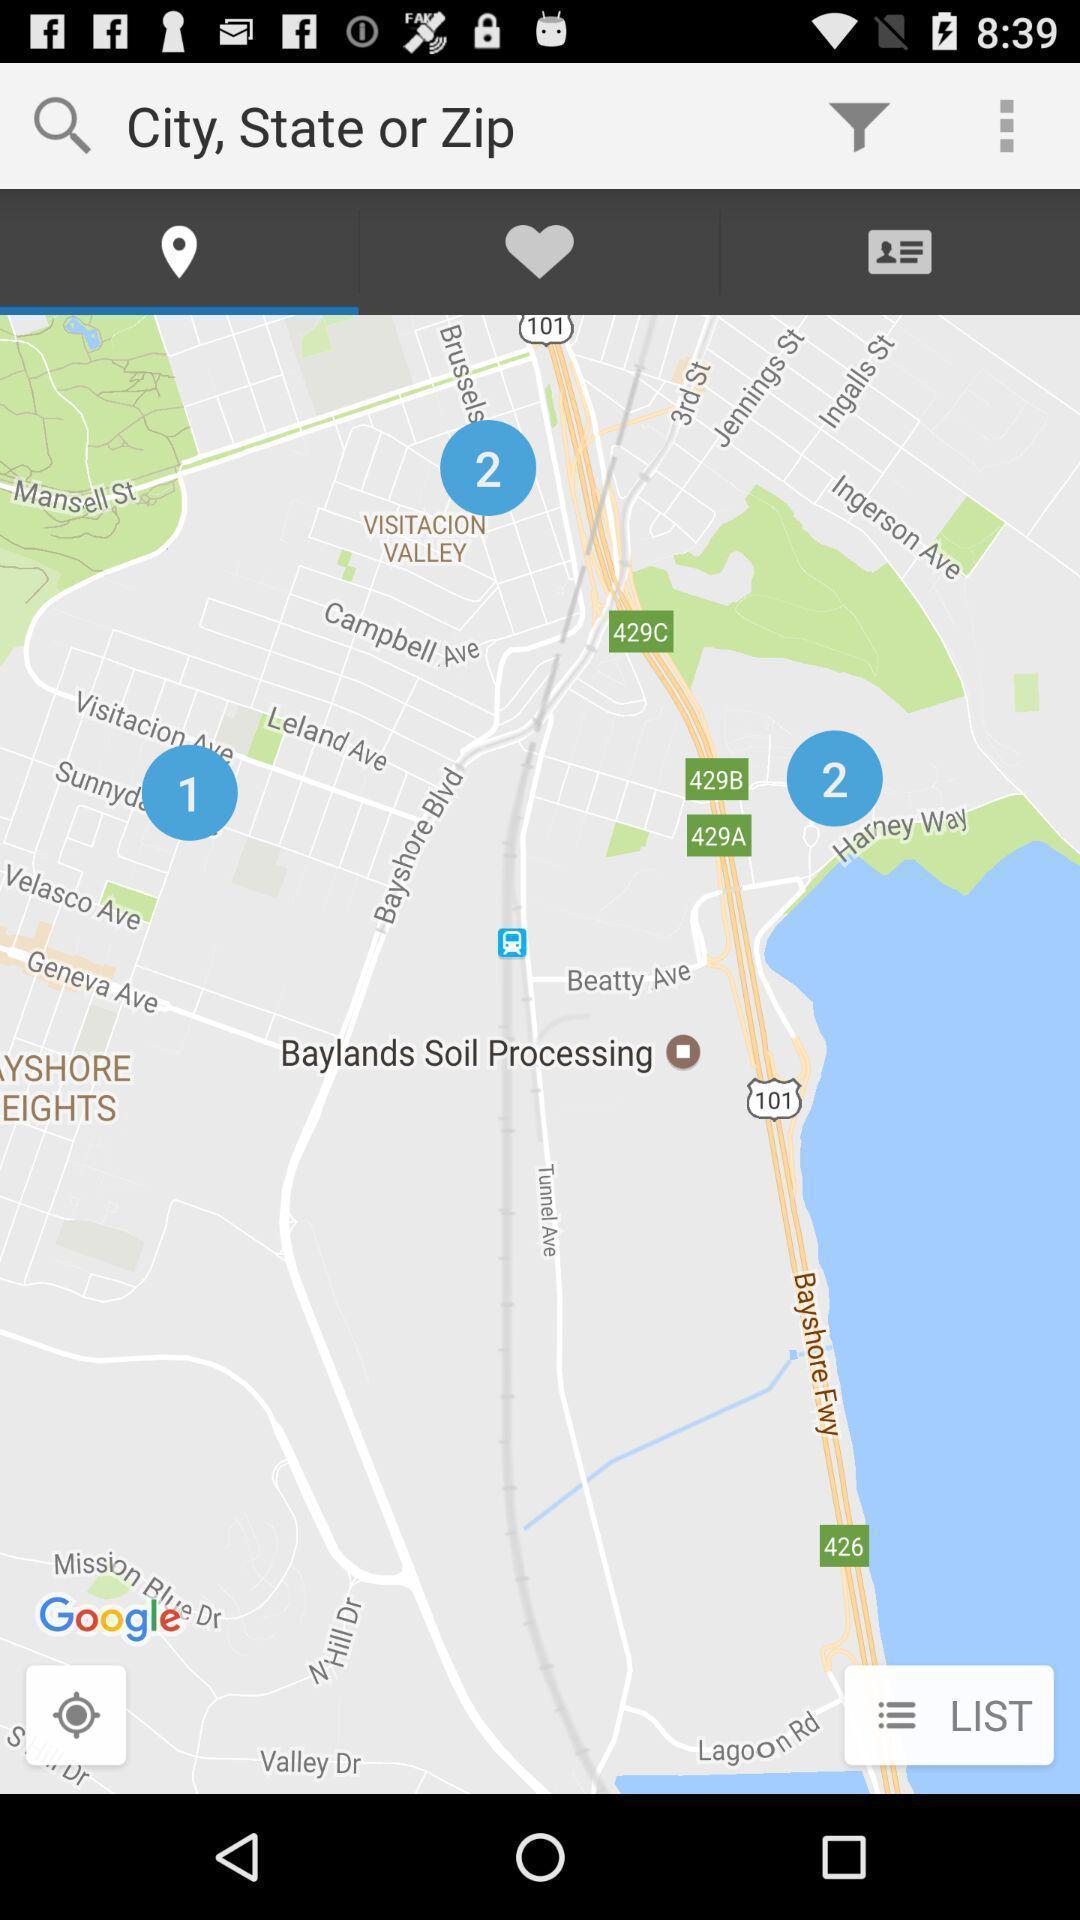Please provide a description for this image. Screen showing map. 